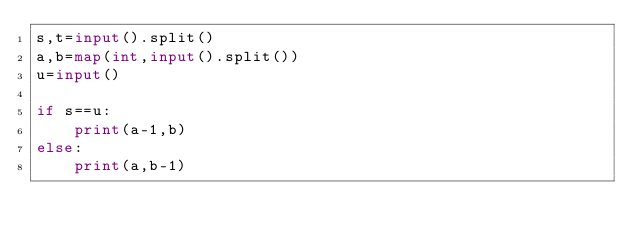<code> <loc_0><loc_0><loc_500><loc_500><_Python_>s,t=input().split()
a,b=map(int,input().split())
u=input()

if s==u:
    print(a-1,b)
else:
    print(a,b-1)</code> 